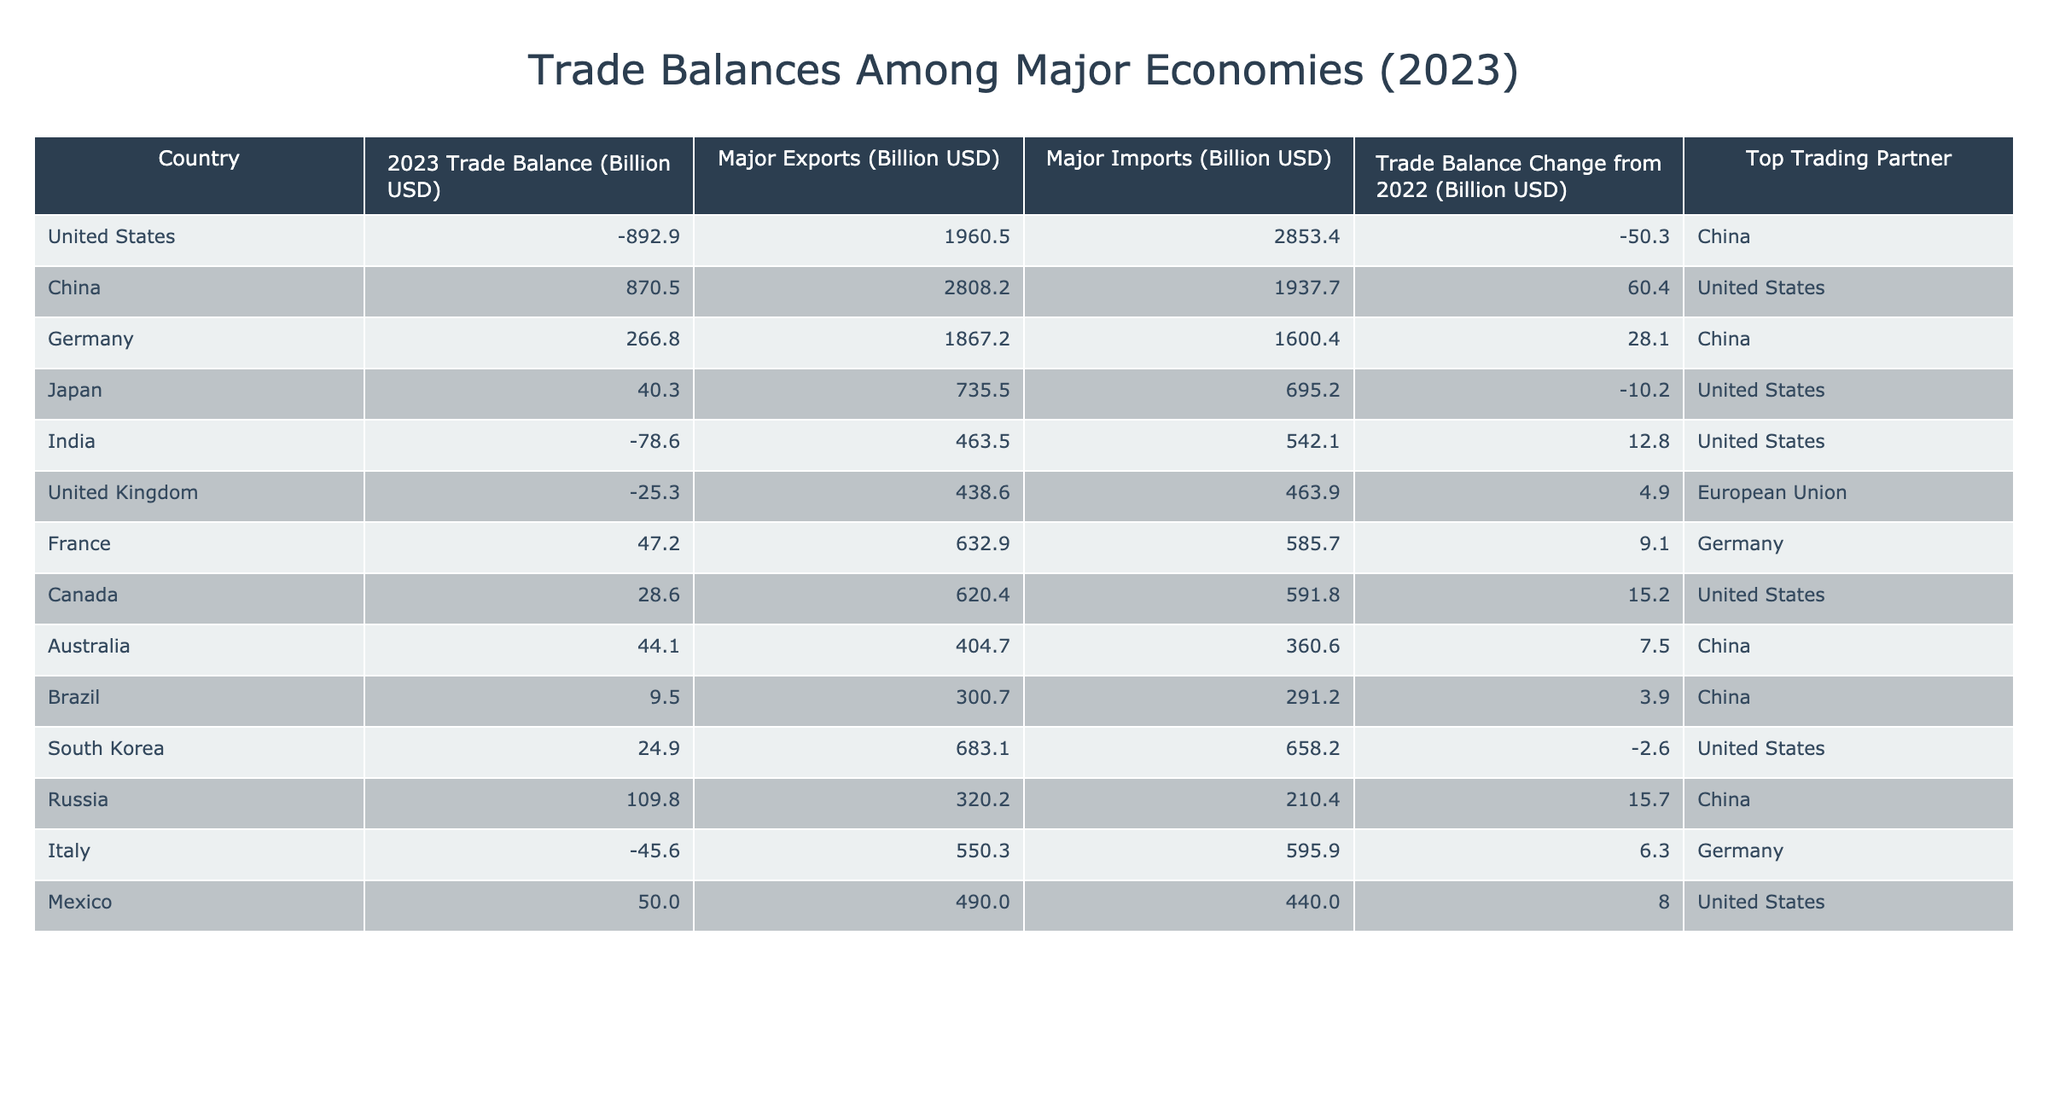What is the trade balance of China in 2023? According to the table, China has a trade balance of +870.5 billion USD in 2023.
Answer: +870.5 billion USD Which country has the largest trade deficit in 2023? The table shows that the United States has the largest trade deficit at -892.9 billion USD in 2023.
Answer: United States Did Germany's trade balance improve compared to 2022? The trade balance change from 2022 for Germany is +28.1 billion USD, indicating an improvement.
Answer: Yes What are the total major exports of India in 2023? India’s major exports in 2023 amount to 463.5 billion USD as shown in the table.
Answer: 463.5 billion USD What is the difference between the major exports and imports of Brazil in 2023? Brazil’s major exports are 300.7 billion USD, and its major imports are 291.2 billion USD. The difference is 300.7 - 291.2 = 9.5 billion USD.
Answer: 9.5 billion USD Which country has the highest major imports in the table? The United States has the highest major imports at 2853.4 billion USD listed in the table.
Answer: United States What is the average trade balance of the countries listed in the table? Adding up the trade balances gives -892.9 + 870.5 + 266.8 + 40.3 - 78.6 - 25.3 + 47.2 + 28.6 + 44.1 + 9.5 + 24.9 + 109.8 - 45.6 + 50.0 = 329.0 billion USD. Then dividing by 14 countries gives an average of 23.5 billion USD.
Answer: 23.5 billion USD Which country has a trade balance that is positive but less than 50 billion USD? The countries that have a positive trade balance less than 50 billion USD are Japan with +40.3 billion USD, and Canada with +28.6 billion USD.
Answer: Japan and Canada How many countries have a trade surplus in 2023? By examining the table, the countries with a positive trade balance (surplus) are China, Germany, Japan, France, Canada, Australia, Brazil, South Korea, Russia, and Mexico, totaling 10 countries.
Answer: 10 countries Is the top trading partner for India the same as for the United States? The top trading partner for India is the United States, while the top trading partner for the United States is China. Therefore, they are not the same.
Answer: No 